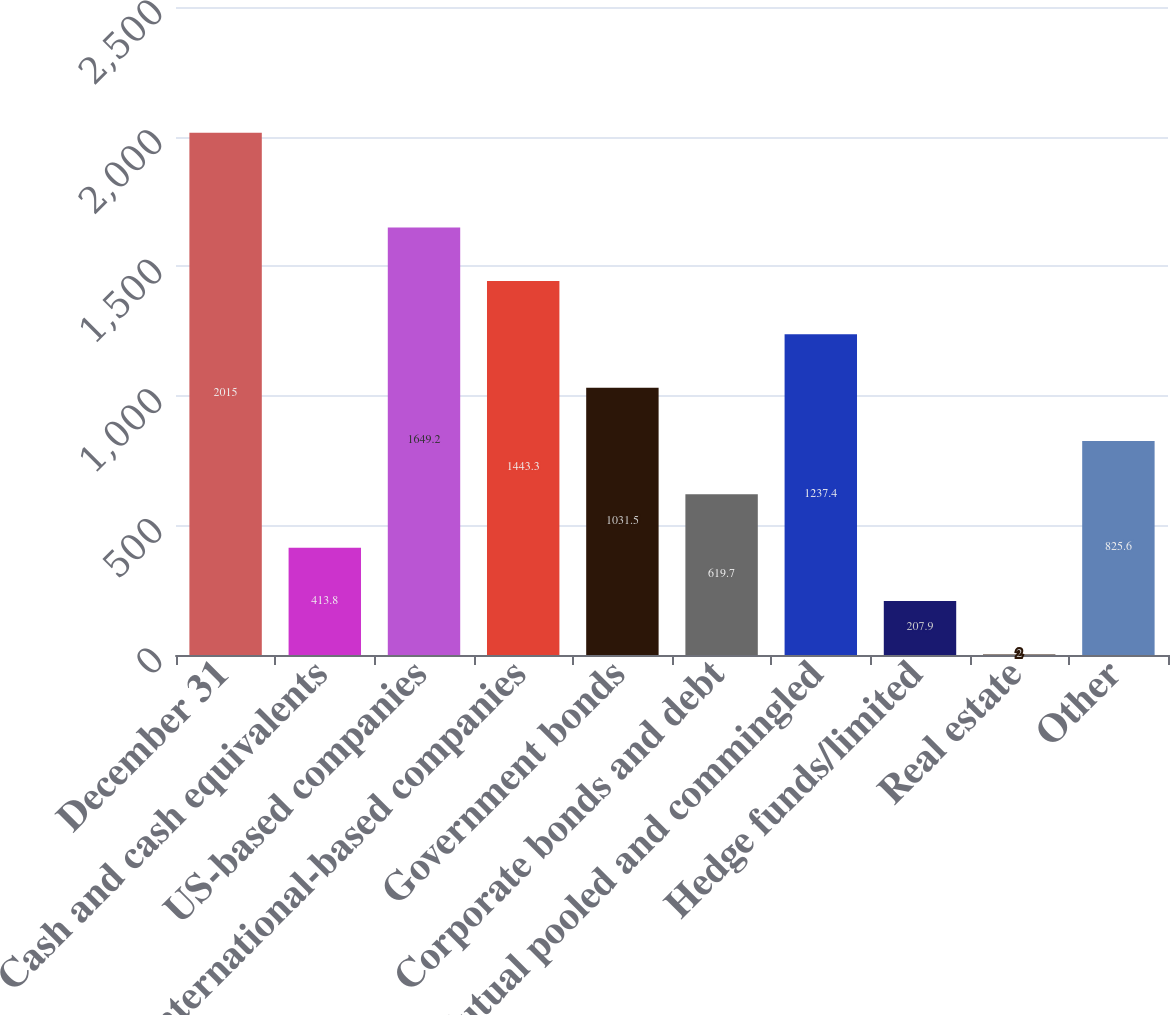<chart> <loc_0><loc_0><loc_500><loc_500><bar_chart><fcel>December 31<fcel>Cash and cash equivalents<fcel>US-based companies<fcel>International-based companies<fcel>Government bonds<fcel>Corporate bonds and debt<fcel>Mutual pooled and commingled<fcel>Hedge funds/limited<fcel>Real estate<fcel>Other<nl><fcel>2015<fcel>413.8<fcel>1649.2<fcel>1443.3<fcel>1031.5<fcel>619.7<fcel>1237.4<fcel>207.9<fcel>2<fcel>825.6<nl></chart> 